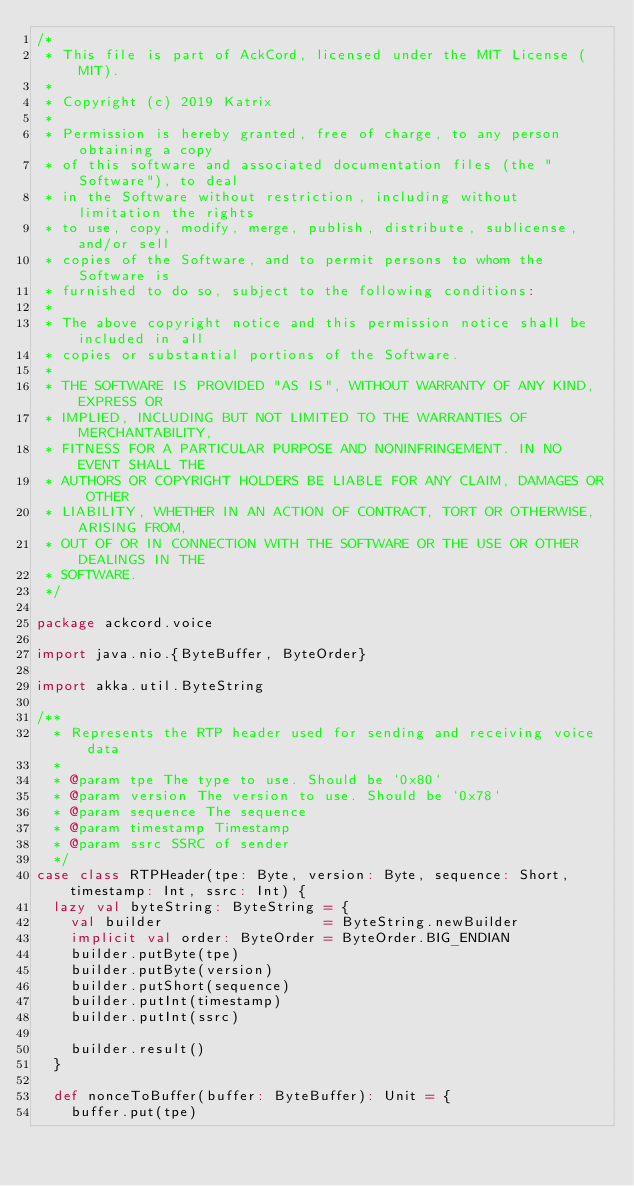<code> <loc_0><loc_0><loc_500><loc_500><_Scala_>/*
 * This file is part of AckCord, licensed under the MIT License (MIT).
 *
 * Copyright (c) 2019 Katrix
 *
 * Permission is hereby granted, free of charge, to any person obtaining a copy
 * of this software and associated documentation files (the "Software"), to deal
 * in the Software without restriction, including without limitation the rights
 * to use, copy, modify, merge, publish, distribute, sublicense, and/or sell
 * copies of the Software, and to permit persons to whom the Software is
 * furnished to do so, subject to the following conditions:
 *
 * The above copyright notice and this permission notice shall be included in all
 * copies or substantial portions of the Software.
 *
 * THE SOFTWARE IS PROVIDED "AS IS", WITHOUT WARRANTY OF ANY KIND, EXPRESS OR
 * IMPLIED, INCLUDING BUT NOT LIMITED TO THE WARRANTIES OF MERCHANTABILITY,
 * FITNESS FOR A PARTICULAR PURPOSE AND NONINFRINGEMENT. IN NO EVENT SHALL THE
 * AUTHORS OR COPYRIGHT HOLDERS BE LIABLE FOR ANY CLAIM, DAMAGES OR OTHER
 * LIABILITY, WHETHER IN AN ACTION OF CONTRACT, TORT OR OTHERWISE, ARISING FROM,
 * OUT OF OR IN CONNECTION WITH THE SOFTWARE OR THE USE OR OTHER DEALINGS IN THE
 * SOFTWARE.
 */

package ackcord.voice

import java.nio.{ByteBuffer, ByteOrder}

import akka.util.ByteString

/**
  * Represents the RTP header used for sending and receiving voice data
  *
  * @param tpe The type to use. Should be `0x80`
  * @param version The version to use. Should be `0x78`
  * @param sequence The sequence
  * @param timestamp Timestamp
  * @param ssrc SSRC of sender
  */
case class RTPHeader(tpe: Byte, version: Byte, sequence: Short, timestamp: Int, ssrc: Int) {
  lazy val byteString: ByteString = {
    val builder                   = ByteString.newBuilder
    implicit val order: ByteOrder = ByteOrder.BIG_ENDIAN
    builder.putByte(tpe)
    builder.putByte(version)
    builder.putShort(sequence)
    builder.putInt(timestamp)
    builder.putInt(ssrc)

    builder.result()
  }

  def nonceToBuffer(buffer: ByteBuffer): Unit = {
    buffer.put(tpe)</code> 